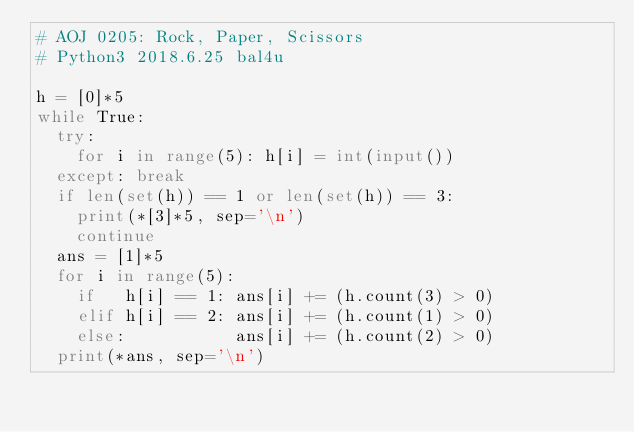Convert code to text. <code><loc_0><loc_0><loc_500><loc_500><_Python_># AOJ 0205: Rock, Paper, Scissors
# Python3 2018.6.25 bal4u

h = [0]*5
while True:
	try:
		for i in range(5): h[i] = int(input())
	except: break
	if len(set(h)) == 1 or len(set(h)) == 3:
		print(*[3]*5, sep='\n')
		continue
	ans = [1]*5
	for i in range(5):
		if   h[i] == 1: ans[i] += (h.count(3) > 0)
		elif h[i] == 2: ans[i] += (h.count(1) > 0)
		else:           ans[i] += (h.count(2) > 0)
	print(*ans, sep='\n')
</code> 